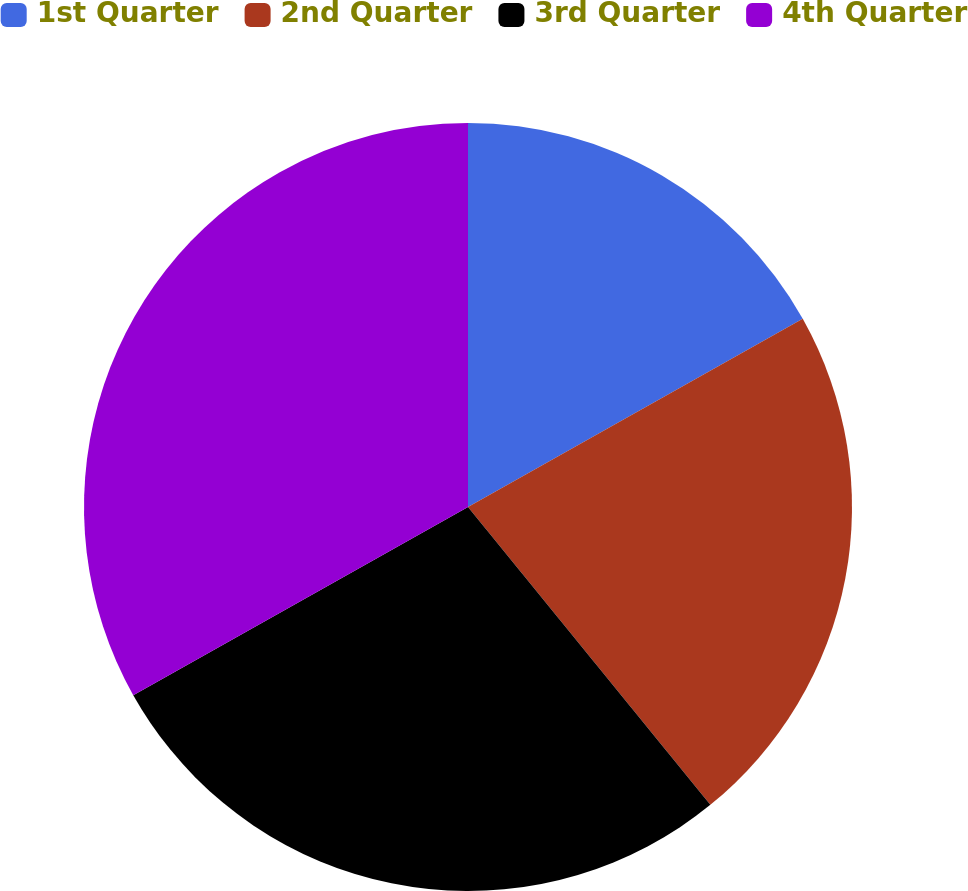<chart> <loc_0><loc_0><loc_500><loc_500><pie_chart><fcel>1st Quarter<fcel>2nd Quarter<fcel>3rd Quarter<fcel>4th Quarter<nl><fcel>16.85%<fcel>22.28%<fcel>27.72%<fcel>33.15%<nl></chart> 